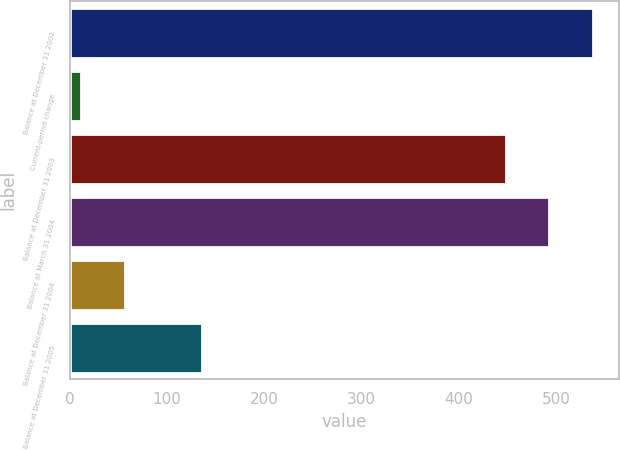<chart> <loc_0><loc_0><loc_500><loc_500><bar_chart><fcel>Balance at December 31 2002<fcel>Current-period change<fcel>Balance at December 31 2003<fcel>Balance at March 31 2004<fcel>Balance at December 31 2004<fcel>Balance at December 31 2005<nl><fcel>537.6<fcel>12<fcel>448<fcel>492.8<fcel>56.8<fcel>136<nl></chart> 